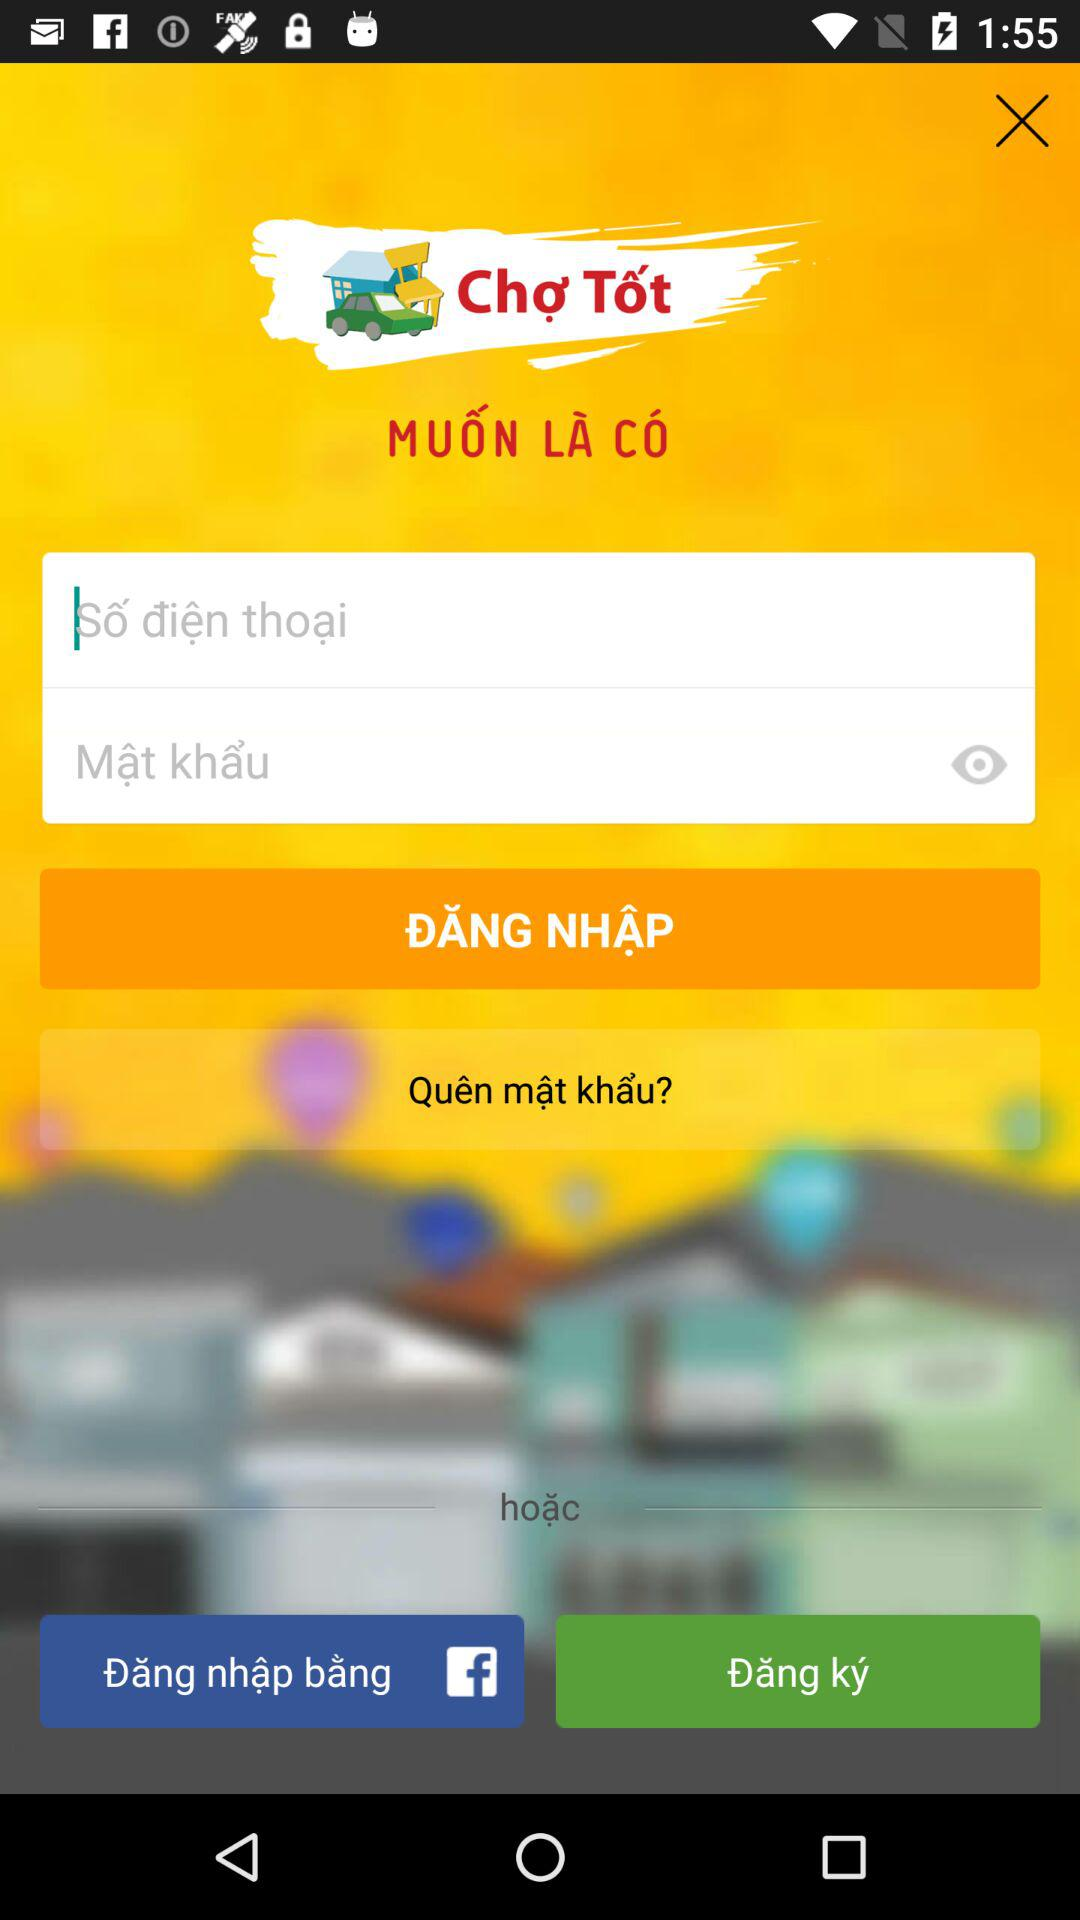How many fields are there to fill out?
Answer the question using a single word or phrase. 2 